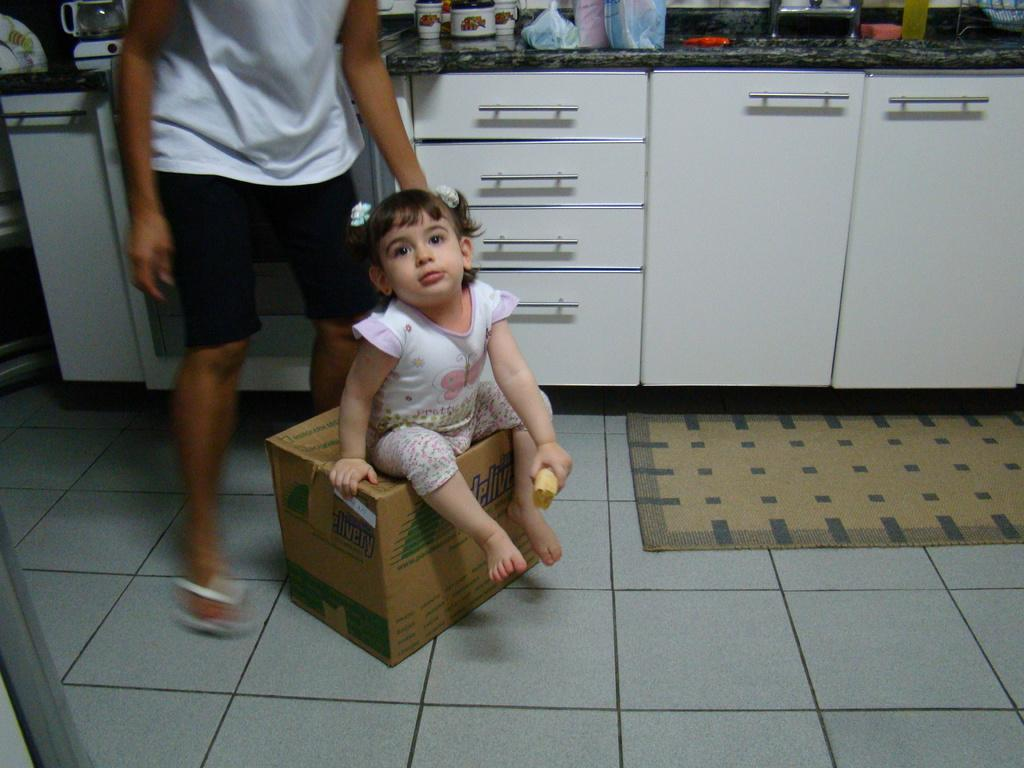Who is the main subject in the image? There is a girl in the image. What is the girl holding in her hand? The girl is holding an object in her hand. What is the girl sitting on? The girl is sitting on a box. What is present on the floor? There is a carpet on the floor. What can be seen on the desk in the image? There are other objects on a desk. What type of objects are present on the plate? The facts do not specify what is on the plate, so we cannot answer that question. Can you tell me how many pets are visible in the image? There are no pets visible in the image. What type of duck is sitting on the girl's shoulder in the image? There is no duck present in the image. 